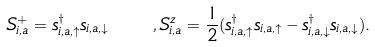Convert formula to latex. <formula><loc_0><loc_0><loc_500><loc_500>S _ { i , a } ^ { + } = s _ { i , a , \uparrow } ^ { \dagger } s _ { i , a , \downarrow } \quad , S _ { i , a } ^ { z } = \frac { 1 } { 2 } ( s _ { i , a , \uparrow } ^ { \dagger } s _ { i , a , \uparrow } - s _ { i , a , \downarrow } ^ { \dagger } s _ { i , a , \downarrow } ) .</formula> 